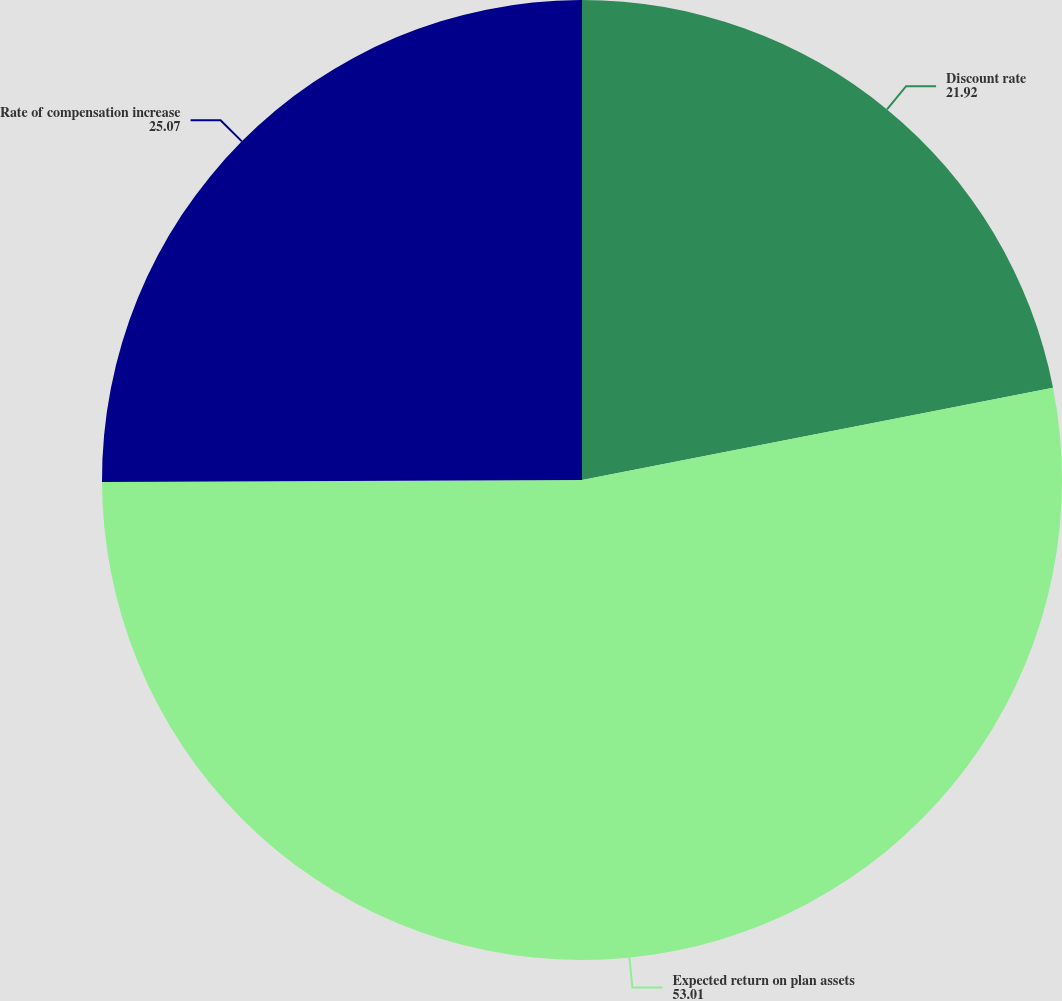<chart> <loc_0><loc_0><loc_500><loc_500><pie_chart><fcel>Discount rate<fcel>Expected return on plan assets<fcel>Rate of compensation increase<nl><fcel>21.92%<fcel>53.01%<fcel>25.07%<nl></chart> 